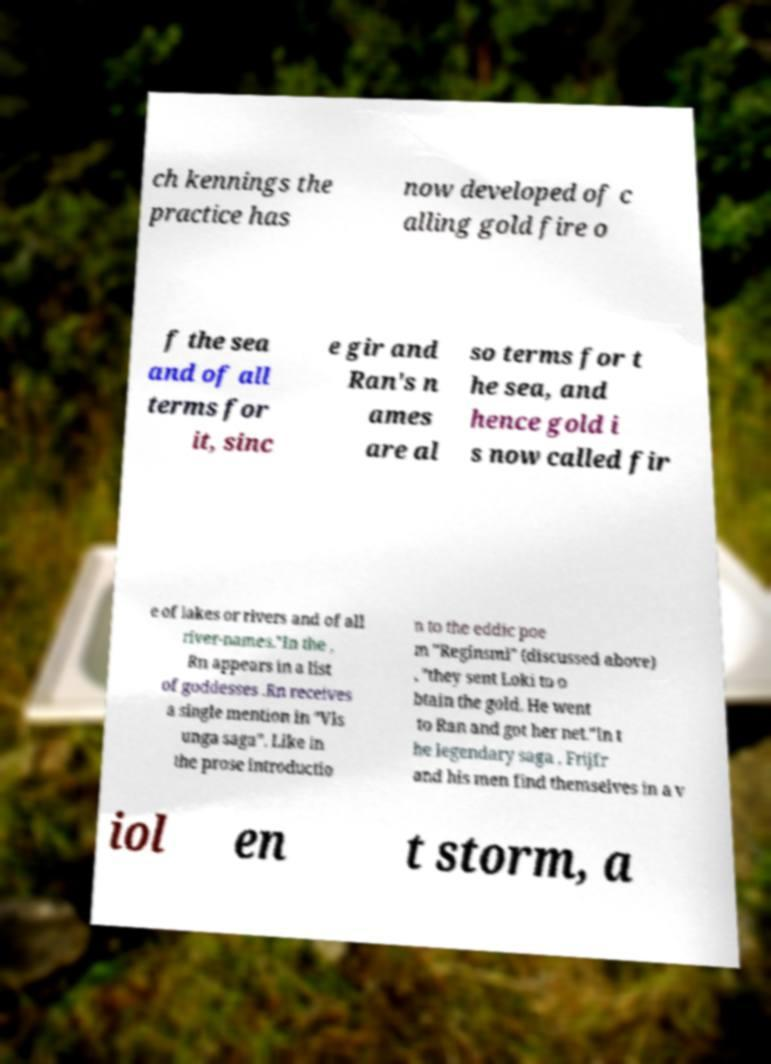Please identify and transcribe the text found in this image. ch kennings the practice has now developed of c alling gold fire o f the sea and of all terms for it, sinc e gir and Ran's n ames are al so terms for t he sea, and hence gold i s now called fir e of lakes or rivers and of all river-names."In the , Rn appears in a list of goddesses .Rn receives a single mention in "Vls unga saga". Like in the prose introductio n to the eddic poe m "Reginsml" (discussed above) , "they sent Loki to o btain the gold. He went to Ran and got her net."In t he legendary saga , Frijfr and his men find themselves in a v iol en t storm, a 